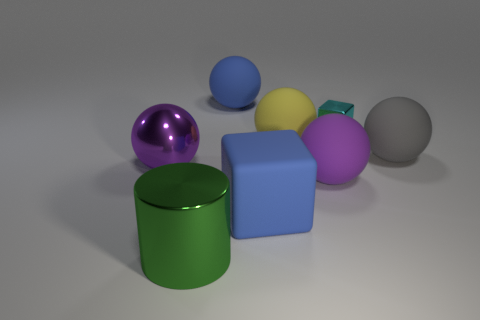What number of other objects are there of the same material as the small cyan object?
Your answer should be very brief. 2. What number of rubber things are large cylinders or cyan cylinders?
Make the answer very short. 0. Are there fewer big blue rubber balls than large purple metal blocks?
Offer a very short reply. No. There is a green metallic cylinder; is it the same size as the block that is in front of the small cube?
Ensure brevity in your answer.  Yes. Is there any other thing that has the same shape as the large green metal thing?
Your response must be concise. No. What is the size of the metallic block?
Your response must be concise. Small. Is the number of cyan shiny objects that are in front of the cyan block less than the number of red metallic objects?
Provide a succinct answer. No. Do the rubber block and the gray object have the same size?
Give a very brief answer. Yes. Is there anything else that has the same size as the cyan thing?
Offer a very short reply. No. The big cube that is made of the same material as the gray thing is what color?
Your response must be concise. Blue. 